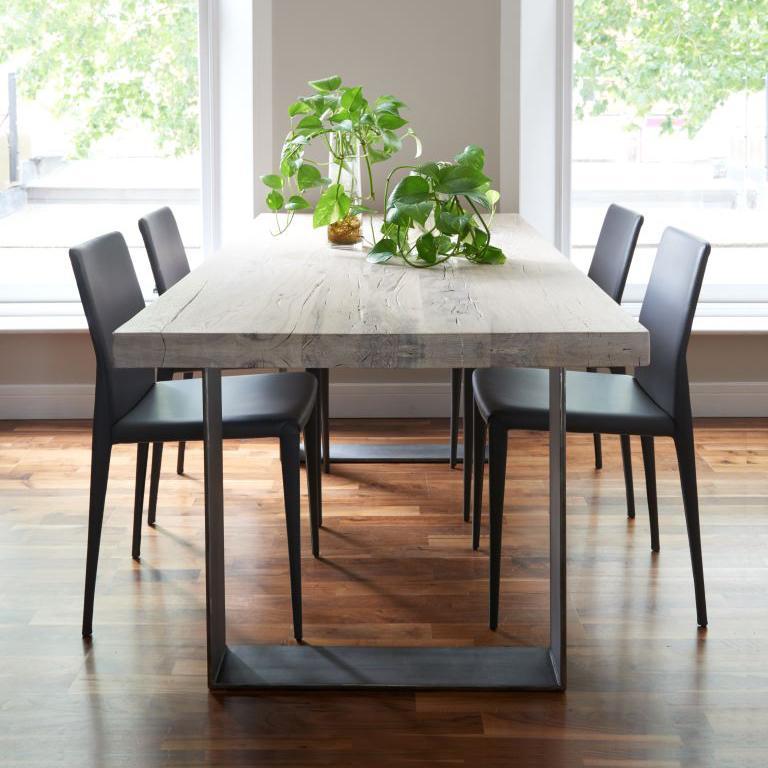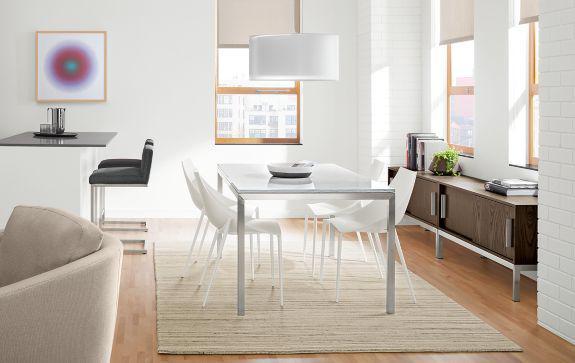The first image is the image on the left, the second image is the image on the right. Considering the images on both sides, is "Two rectangular dining tables have chairs only on both long sides." valid? Answer yes or no. Yes. The first image is the image on the left, the second image is the image on the right. Given the left and right images, does the statement "One image includes a white table with white chairs that feature molded seats." hold true? Answer yes or no. Yes. 